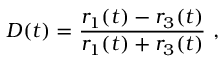<formula> <loc_0><loc_0><loc_500><loc_500>D ( t ) = \frac { r _ { 1 } ( t ) - r _ { 3 } ( t ) } { r _ { 1 } ( t ) + r _ { 3 } ( t ) } \ ,</formula> 